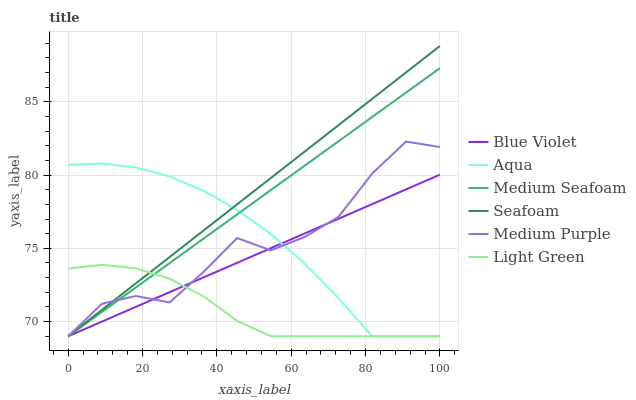Does Light Green have the minimum area under the curve?
Answer yes or no. Yes. Does Medium Purple have the minimum area under the curve?
Answer yes or no. No. Does Medium Purple have the maximum area under the curve?
Answer yes or no. No. Is Medium Seafoam the smoothest?
Answer yes or no. Yes. Is Medium Purple the roughest?
Answer yes or no. Yes. Is Seafoam the smoothest?
Answer yes or no. No. Is Seafoam the roughest?
Answer yes or no. No. Does Medium Purple have the highest value?
Answer yes or no. No. 